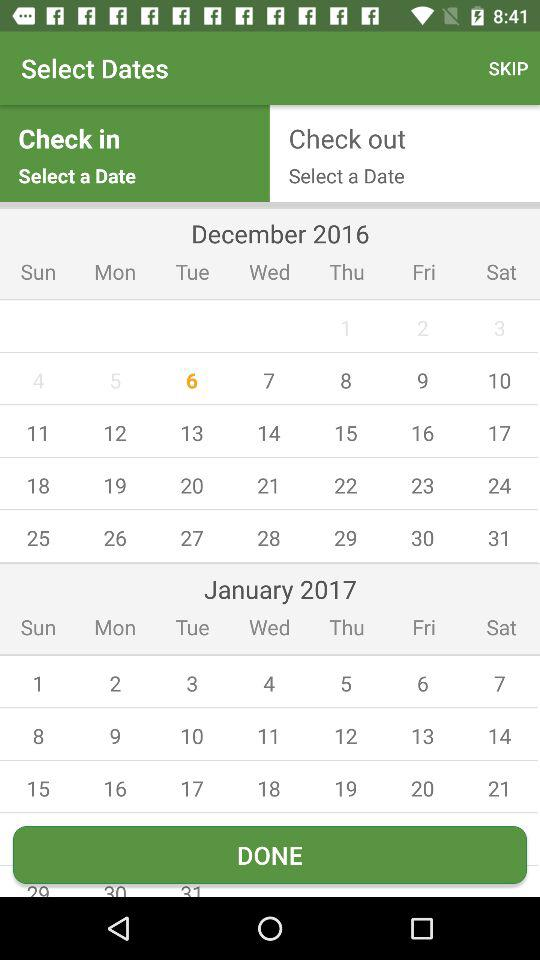What is the day on the selected date?
When the provided information is insufficient, respond with <no answer>. <no answer> 